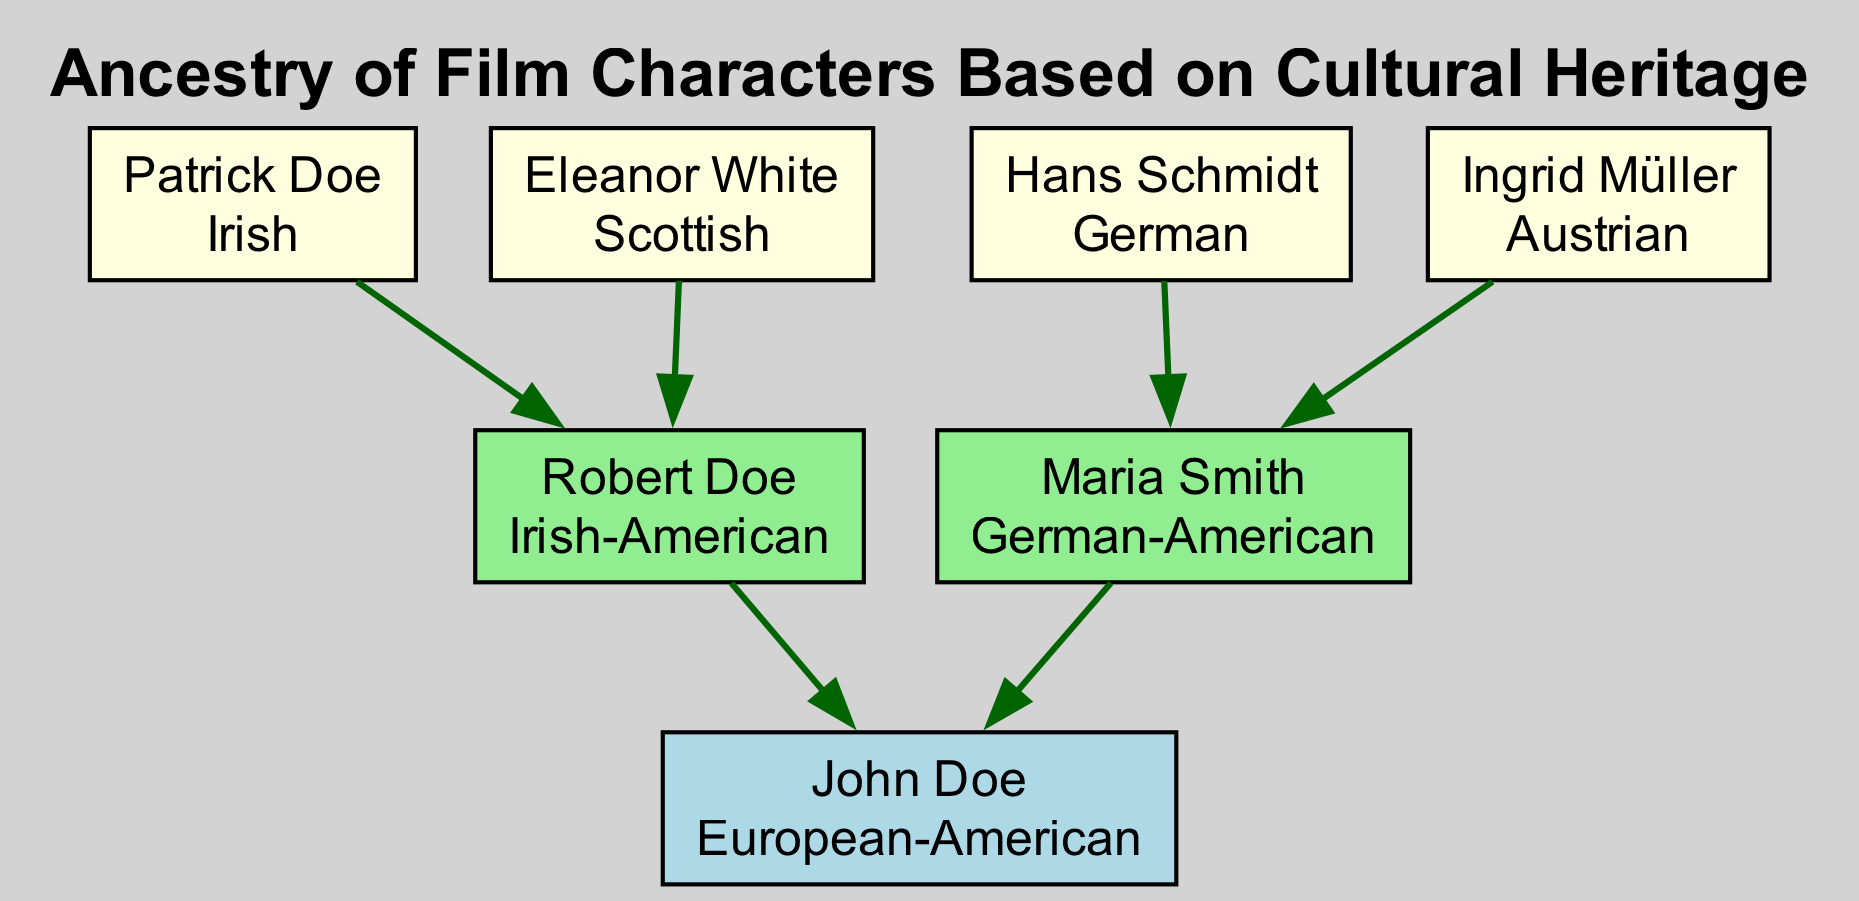What is John Doe's cultural heritage? The diagram identifies John Doe's cultural heritage listed under his name at the root of the tree, which is "European-American."
Answer: European-American How many parents does John Doe have? The diagram shows two individuals directly connected to John Doe as parents, which are Robert Doe and Maria Smith.
Answer: 2 What is the cultural heritage of Robert Doe? Robert Doe's cultural heritage is displayed right next to his name in the diagram, which states that he is "Irish-American."
Answer: Irish-American Who is the grandparent of John Doe with Austrian heritage? By examining the grandparent nodes listed under the grandparents section, Ingrid Müller is identified with "Austrian" cultural heritage.
Answer: Ingrid Müller Which cultural heritage appears most frequently in the grandparent generation? The diagram reveals the cultural heritages of all four grandparents listed, and both Irish and German appear twice as they are represented by Patrick Doe, Eleanor White, Hans Schmidt, and Ingrid Müller. Therefore, the most frequent heritages are Irish and German.
Answer: Irish, German Which cultural heritage does Maria Smith represent? Maria Smith's name in the diagram has the cultural heritage right beneath it, which shows "German-American."
Answer: German-American How many total grandparents does John Doe have? The grandparents section of the diagram lists four individual boxes representing the grandparents of John Doe.
Answer: 4 What is the relationship of Eleanor White to John Doe? Eleanor White is shown connected through a direct lineage as a grandparent to John Doe in the diagram, making her his grandparent.
Answer: Grandparent Which grandparent is identified as Scottish? The diagram indicates Eleanor White as having the cultural heritage of "Scottish," confirming her identity as the Scottish grandparent of John Doe.
Answer: Eleanor White 